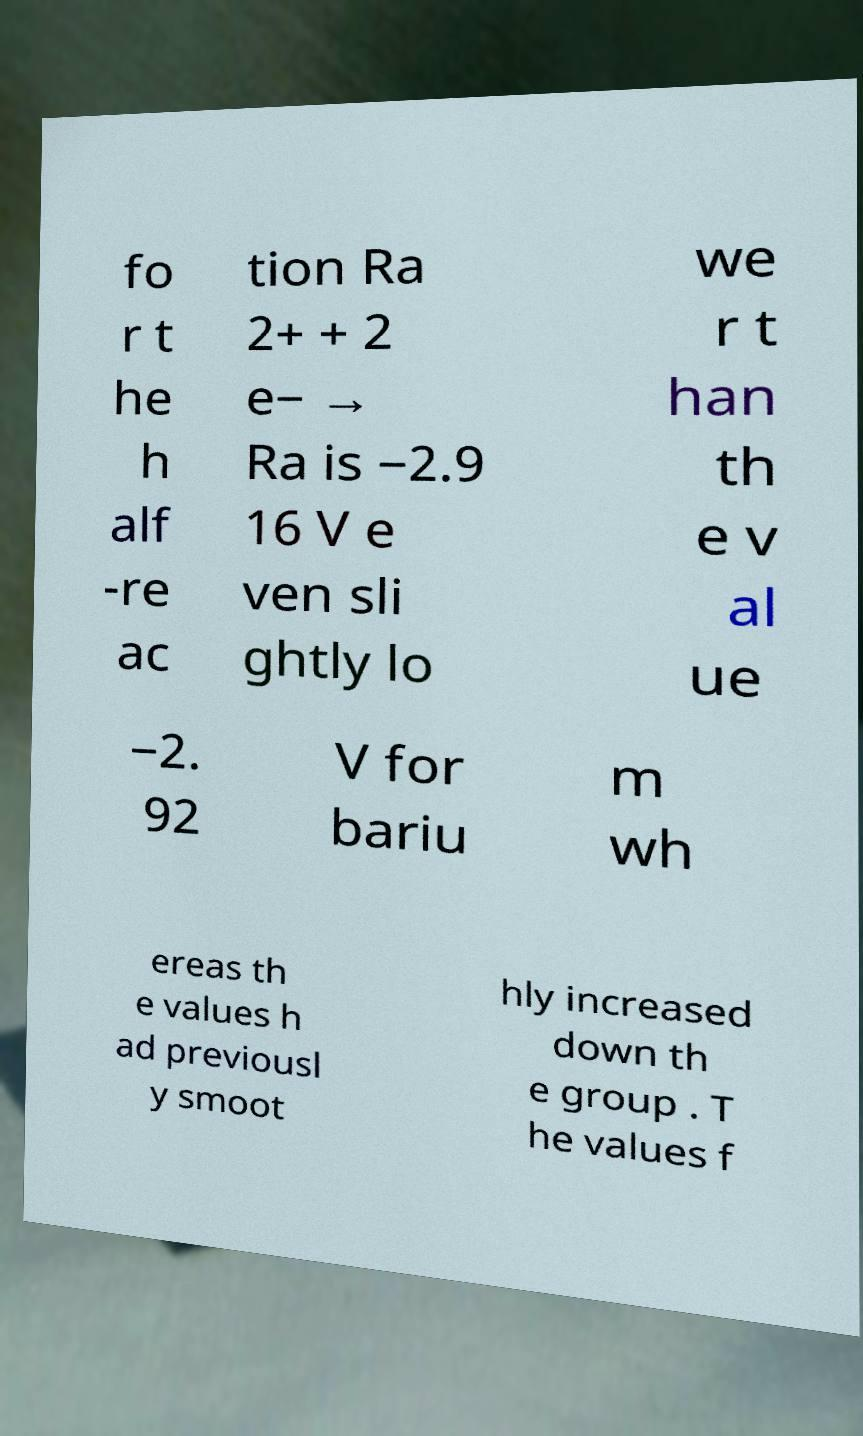Please identify and transcribe the text found in this image. fo r t he h alf -re ac tion Ra 2+ + 2 e− → Ra is −2.9 16 V e ven sli ghtly lo we r t han th e v al ue −2. 92 V for bariu m wh ereas th e values h ad previousl y smoot hly increased down th e group . T he values f 